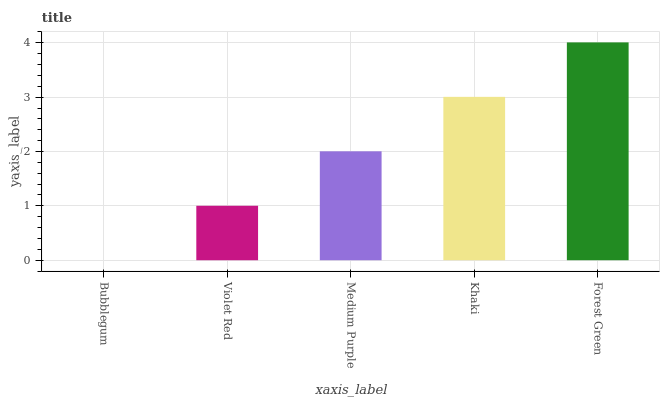Is Bubblegum the minimum?
Answer yes or no. Yes. Is Forest Green the maximum?
Answer yes or no. Yes. Is Violet Red the minimum?
Answer yes or no. No. Is Violet Red the maximum?
Answer yes or no. No. Is Violet Red greater than Bubblegum?
Answer yes or no. Yes. Is Bubblegum less than Violet Red?
Answer yes or no. Yes. Is Bubblegum greater than Violet Red?
Answer yes or no. No. Is Violet Red less than Bubblegum?
Answer yes or no. No. Is Medium Purple the high median?
Answer yes or no. Yes. Is Medium Purple the low median?
Answer yes or no. Yes. Is Bubblegum the high median?
Answer yes or no. No. Is Violet Red the low median?
Answer yes or no. No. 